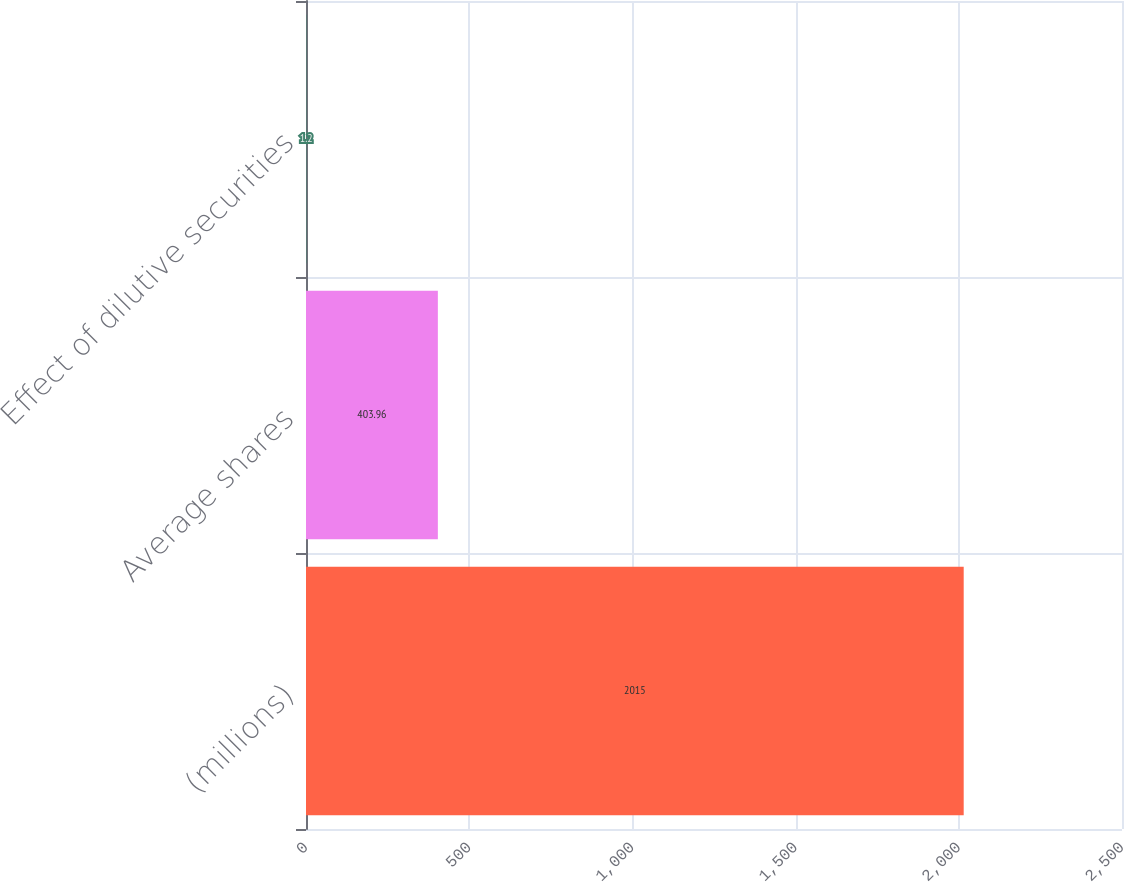<chart> <loc_0><loc_0><loc_500><loc_500><bar_chart><fcel>(millions)<fcel>Average shares<fcel>Effect of dilutive securities<nl><fcel>2015<fcel>403.96<fcel>1.2<nl></chart> 